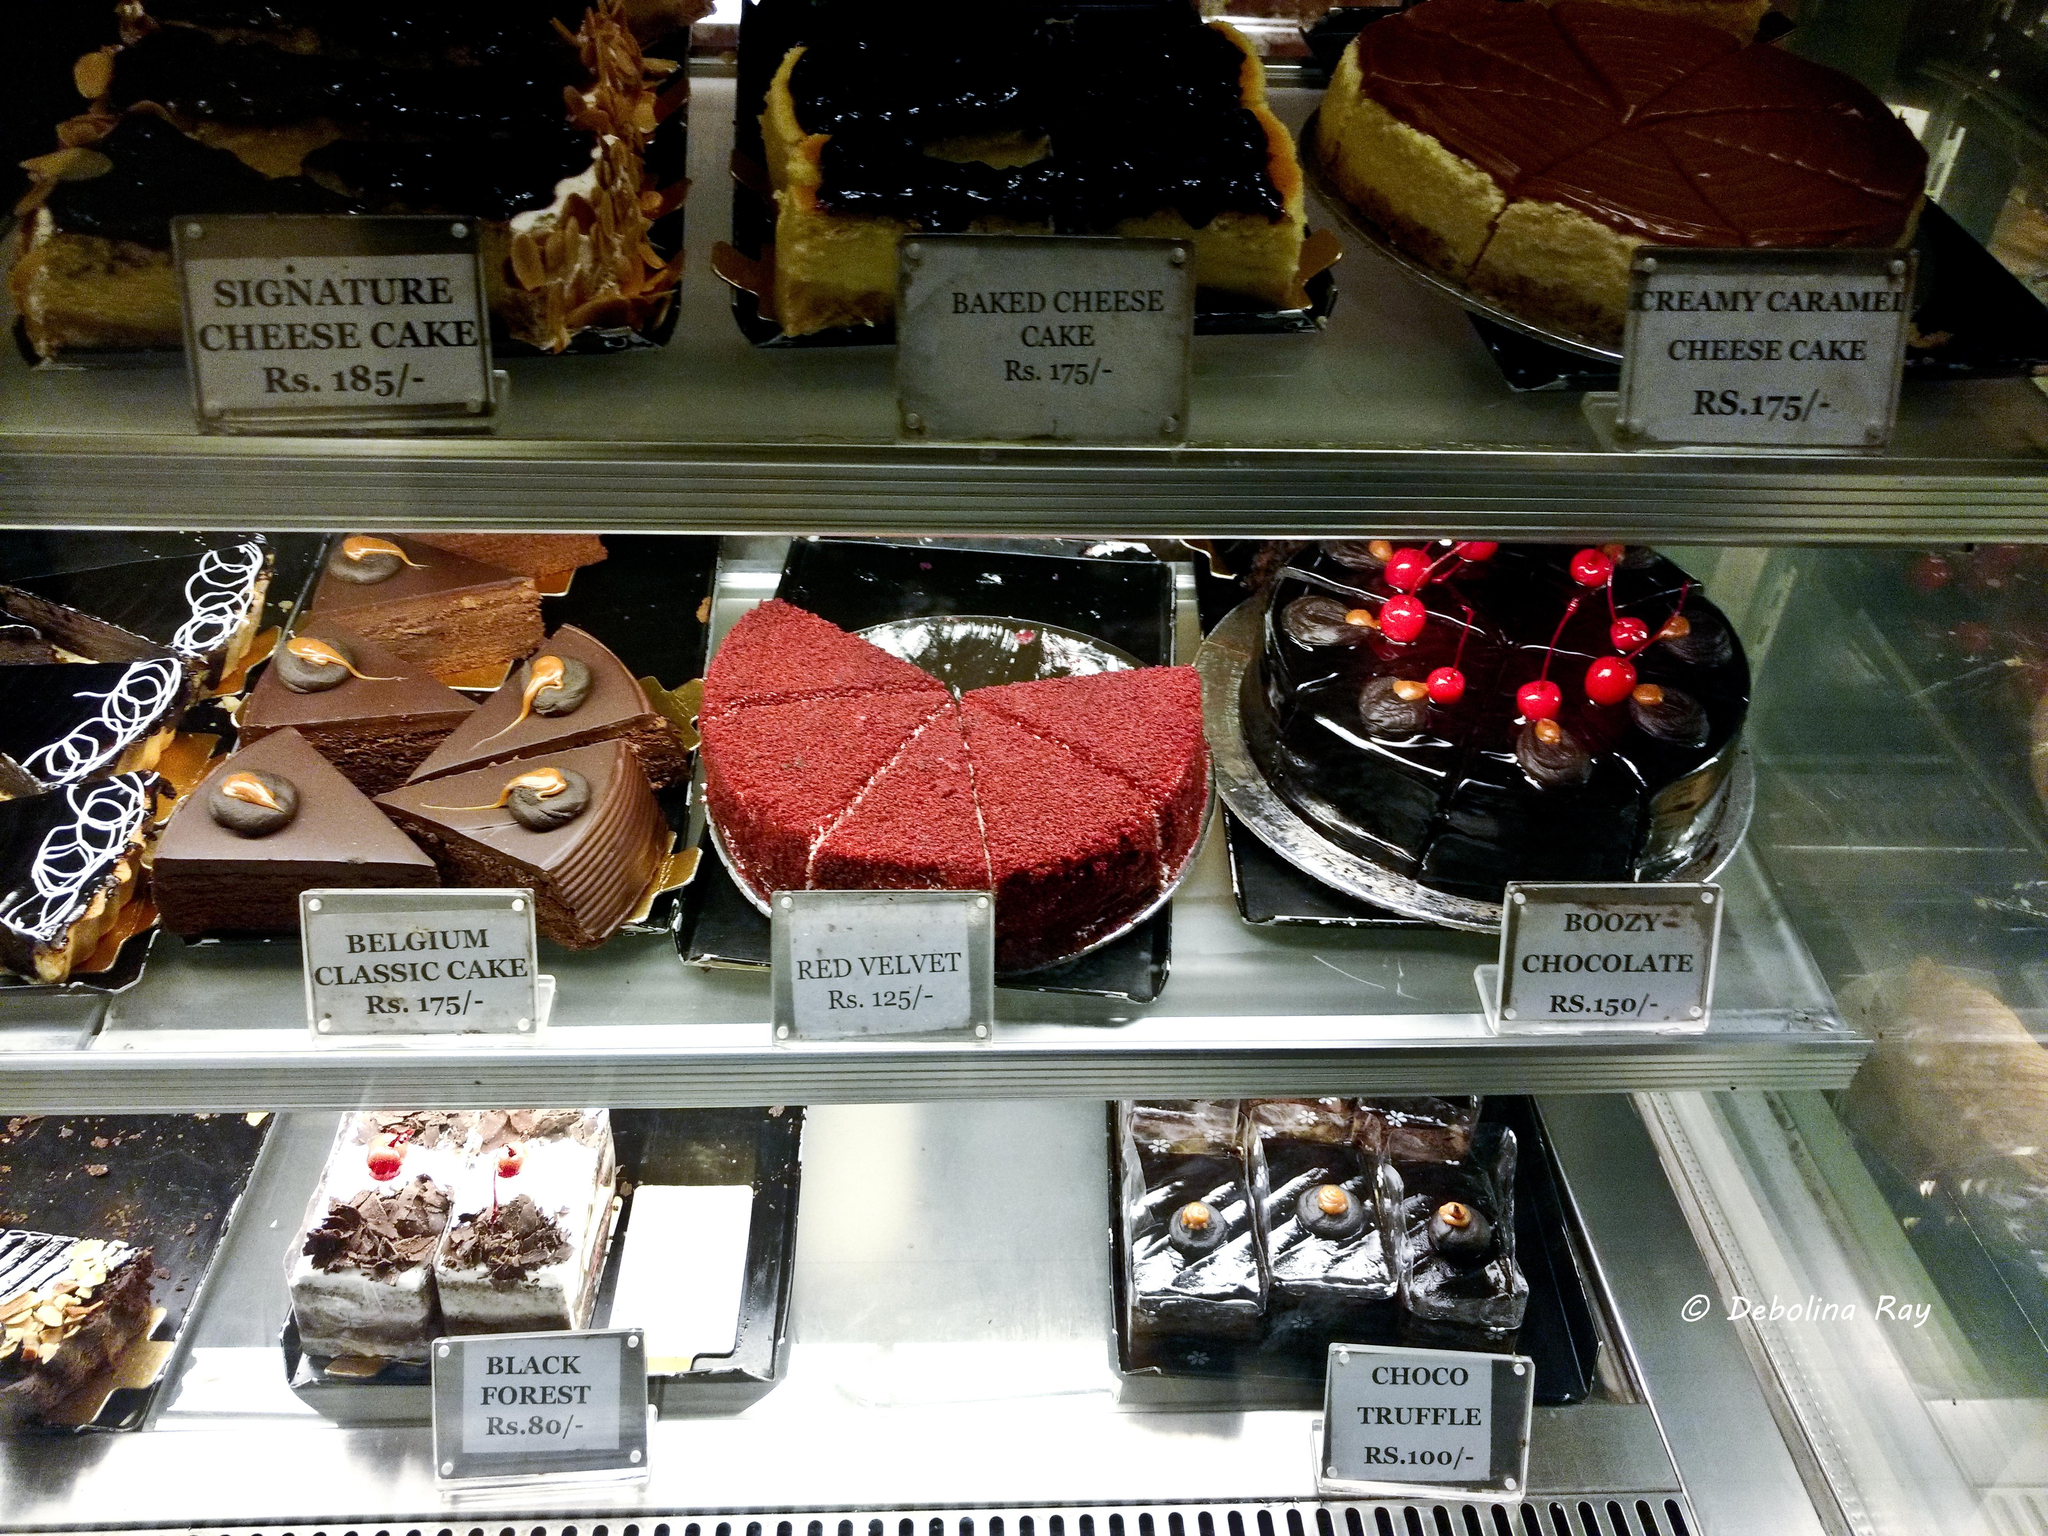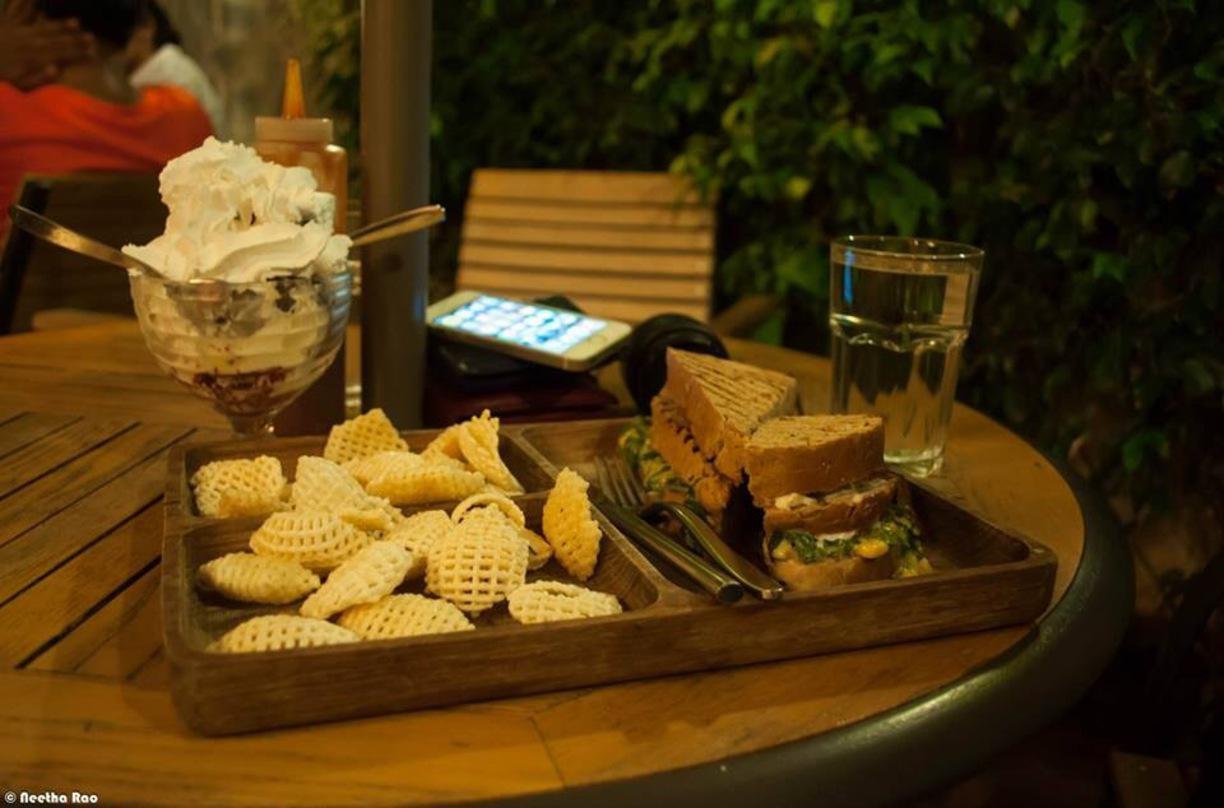The first image is the image on the left, the second image is the image on the right. Evaluate the accuracy of this statement regarding the images: "A glass case holds at least two whole, unsliced red velvet cakes.". Is it true? Answer yes or no. No. 